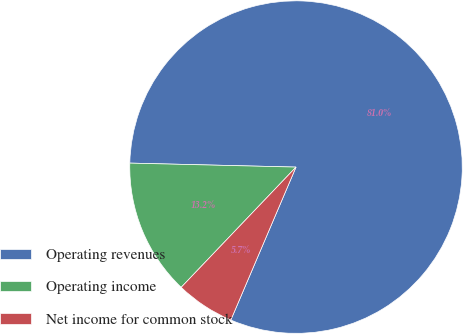Convert chart to OTSL. <chart><loc_0><loc_0><loc_500><loc_500><pie_chart><fcel>Operating revenues<fcel>Operating income<fcel>Net income for common stock<nl><fcel>81.03%<fcel>13.25%<fcel>5.72%<nl></chart> 